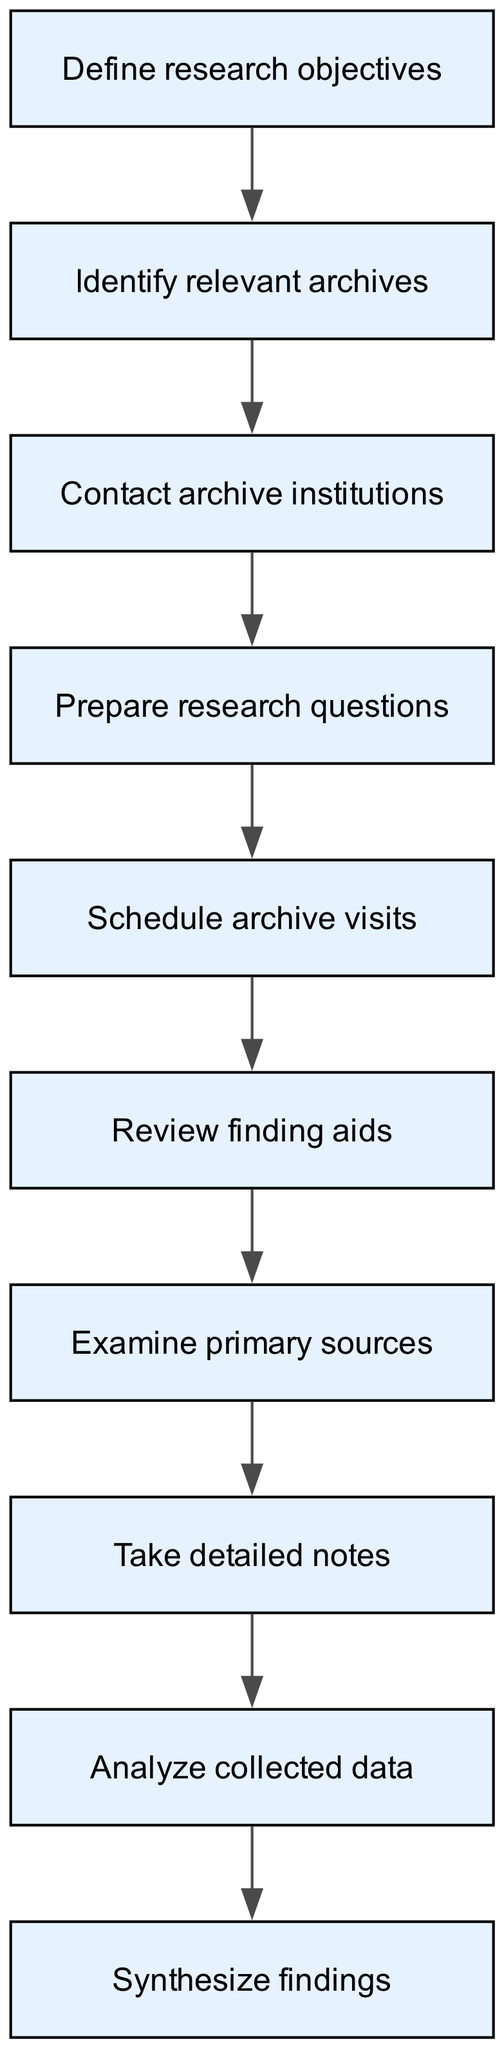What is the starting node of the diagram? The starting node is indicated as the first node in the flow chart, which is "Define research objectives."
Answer: Define research objectives How many nodes are present in the diagram? The total number of nodes includes the starting node and all subsequent nodes. There are 9 nodes in total: one start node and eight additional nodes.
Answer: 9 What is the last step in the research process? The final node in the flow chart sequence shows the endpoint of the research process, which is "Synthesize findings."
Answer: Synthesize findings Which node follows "Review finding aids"? By examining the directed edges, "Examine primary sources" directly follows "Review finding aids."
Answer: Examine primary sources What is the relationship between "Prepare research questions" and "Schedule archive visits"? "Prepare research questions" is connected to "Schedule archive visits" as a directed edge in the flow chart, showing that the second step follows the first.
Answer: Schedule archive visits How many edges are in the diagram? The count of edges can be determined by the connections made between nodes; there are 8 edges linking the nodes in the flow chart.
Answer: 8 What does the transition from "Contact archive institutions" to "Prepare research questions" indicate? This transition indicates a sequential relationship where contacting archives precedes the formulation of research questions, meaning one step logically follows another.
Answer: Prepare research questions Which two nodes are directly connected to "Take detailed notes"? The nodes connected to "Take detailed notes" are "Examine primary sources" (which comes before it) and "Analyze collected data" (which follows it), illustrating a flow of actions in the research process.
Answer: Examine primary sources, Analyze collected data What step occurs immediately after "Schedule archive visits"? Following the step of scheduling visits, the next action to be undertaken according to the flowchart is "Review finding aids."
Answer: Review finding aids 